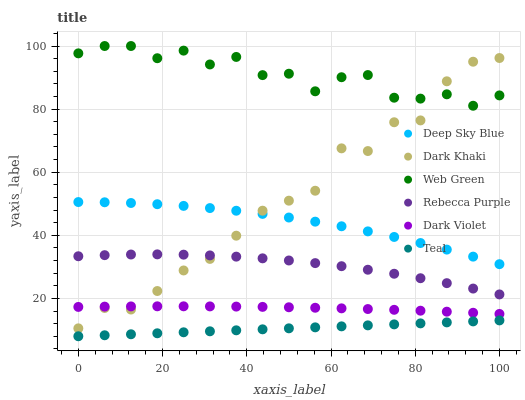Does Teal have the minimum area under the curve?
Answer yes or no. Yes. Does Web Green have the maximum area under the curve?
Answer yes or no. Yes. Does Dark Violet have the minimum area under the curve?
Answer yes or no. No. Does Dark Violet have the maximum area under the curve?
Answer yes or no. No. Is Teal the smoothest?
Answer yes or no. Yes. Is Dark Khaki the roughest?
Answer yes or no. Yes. Is Dark Violet the smoothest?
Answer yes or no. No. Is Dark Violet the roughest?
Answer yes or no. No. Does Teal have the lowest value?
Answer yes or no. Yes. Does Dark Violet have the lowest value?
Answer yes or no. No. Does Web Green have the highest value?
Answer yes or no. Yes. Does Dark Violet have the highest value?
Answer yes or no. No. Is Rebecca Purple less than Deep Sky Blue?
Answer yes or no. Yes. Is Deep Sky Blue greater than Teal?
Answer yes or no. Yes. Does Dark Khaki intersect Deep Sky Blue?
Answer yes or no. Yes. Is Dark Khaki less than Deep Sky Blue?
Answer yes or no. No. Is Dark Khaki greater than Deep Sky Blue?
Answer yes or no. No. Does Rebecca Purple intersect Deep Sky Blue?
Answer yes or no. No. 